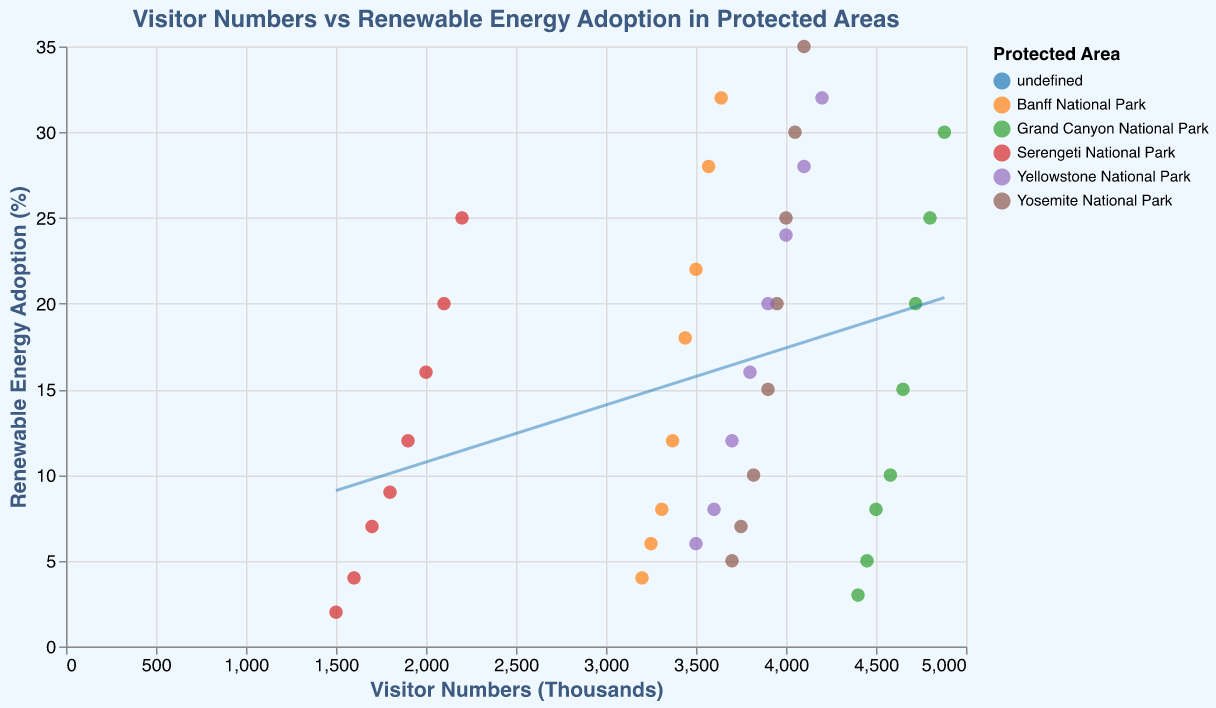what is the relationship between the visitor numbers and renewable energy adoption in Yosemite National Park? By observing the scatter plot with trend lines, we can see the data points for Yosemite National Park, which are color-coded. The data points show that as the visitor numbers increase, the renewable energy adoption percentage also increases. The trend line for Yosemite National Park would highlight this positive correlation.
Answer: Positive correlation How does the increase in renewable energy adoption compare between Yosemite and Serengeti? To compare the increase in renewable energy adoption between Yosemite and Serengeti, we can look at the trend lines and data points for both parks. Over time, Yosemite's renewable energy percentage increased from 5% to 35%, while Serengeti's increased from 2% to 25%. Yosemite shows a higher increase both in absolute percentage points and the gradient of the trend line.
Answer: Yosemite has a higher increase Which protected area had the highest increase in visitor numbers from 2010 to 2017? By analyzing the data points for each protected area, we observe that the Grand Canyon National Park had the highest increase in visitor numbers from 4,400,000 in 2010 to 4,880,000 in 2017.
Answer: Grand Canyon National Park What does the trend line represent in the scatter plot? The trend line represents the regression of renewable energy adoption percentage on visitor numbers, showing the general relationship between the two variables. It helps identify trends and correlations within the data.
Answer: Regression of renewable energy on visitor numbers Which protected area had the lowest starting point for renewable energy adoption in 2010? Looking at the data points from 2010 on the y-axis, Serengeti National Park started with 2%, the lowest renewable energy adoption percentage among the listed protected areas.
Answer: Serengeti National Park Between 2010 and 2017, how does the visitor number growth rate compare between Banff and Yellowstone National Parks? To determine the growth rates, calculate the differences in visitor numbers for both parks from 2010 to 2017. Banff had an increase from 3,200,000 to 3,640,000 (440,000 visitors), while Yellowstone had an increase from 3,500,000 to 4,200,000 (700,000 visitors). Yellowstone had a higher growth rate in visitor numbers.
Answer: Yellowstone had a higher growth rate How many parks are represented in the scatter plot? By examining the color legend in the scatter plot, we see that there are five protected areas represented: Yosemite National Park, Grand Canyon National Park, Banff National Park, Serengeti National Park, and Yellowstone National Park.
Answer: Five Is there any park where the renewable energy adoption is not showing a consistent increase? By analyzing the scatter plot and the trend lines for each protected area, we observe that all parks show a consistent increase in renewable energy adoption over the years. No park shows a decrease or inconsistency in the percentage.
Answer: No What can you say about the data distribution for protected areas with lower visitor numbers? From the scatter plot, we observe that protected areas with lower visitor numbers, such as Serengeti and Banff, tend to have lower renewable energy adoption percentages compared to those with higher visitor numbers.
Answer: Lower renewable energy adoption percentages 